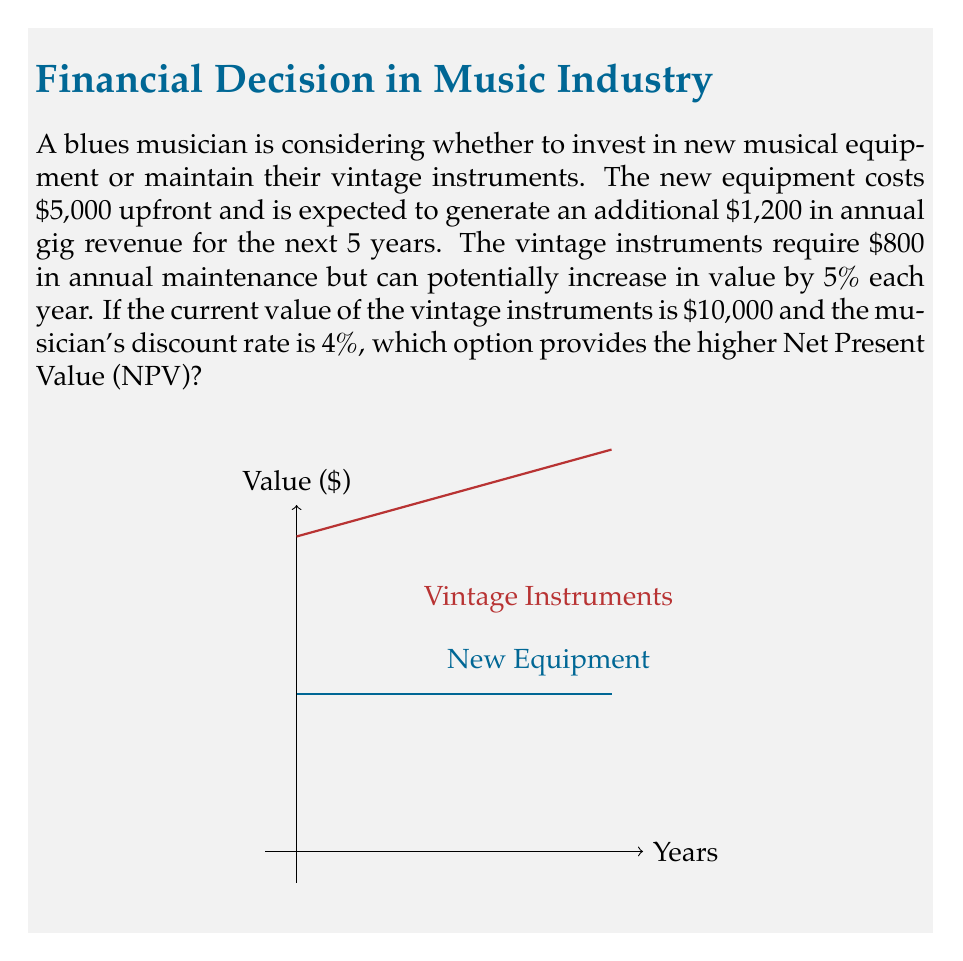Can you answer this question? Let's calculate the NPV for both options:

1. New Equipment:
   - Initial cost: -$5,000
   - Annual cash flow: $1,200 for 5 years
   - NPV calculation:
     $$NPV_{new} = -5000 + \sum_{t=1}^{5} \frac{1200}{(1.04)^t}$$
     $$NPV_{new} = -5000 + 1200 \cdot \frac{1-(1.04)^{-5}}{0.04}$$
     $$NPV_{new} = -5000 + 1200 \cdot 4.4518 = 341.16$$

2. Vintage Instruments:
   - Initial value: $10,000
   - Annual maintenance cost: -$800
   - Annual appreciation: 5%
   - NPV calculation:
     $$NPV_{vintage} = \sum_{t=1}^{5} \frac{-800 + 10000 \cdot 0.05}{(1.04)^t} + \frac{10000 \cdot (1.05)^5}{(1.04)^5}$$
     $$NPV_{vintage} = (-800 + 500) \cdot \frac{1-(1.04)^{-5}}{0.04} + \frac{10000 \cdot 1.2763}{1.2167}$$
     $$NPV_{vintage} = -300 \cdot 4.4518 + 10486.15 = 9153.61$$

The NPV of maintaining the vintage instruments ($9,153.61) is higher than the NPV of investing in new equipment ($341.16).
Answer: $9,153.61 (Vintage instruments option) 